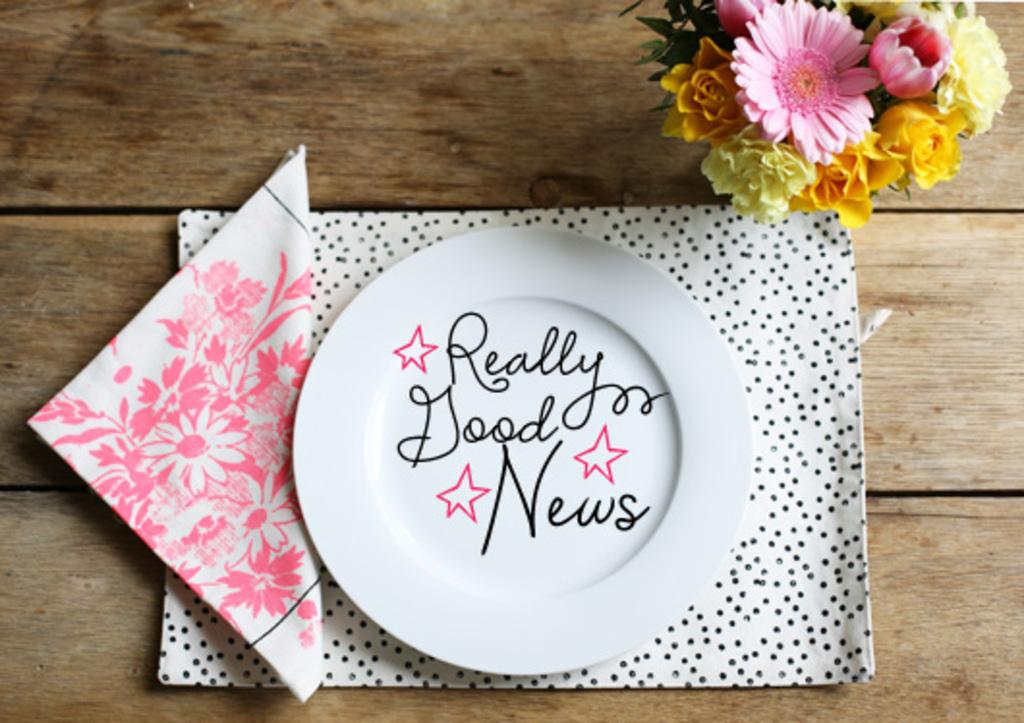<image>
Offer a succinct explanation of the picture presented. A plate with the inscription "Really Good News" sits on a place mat next to a napkin. 